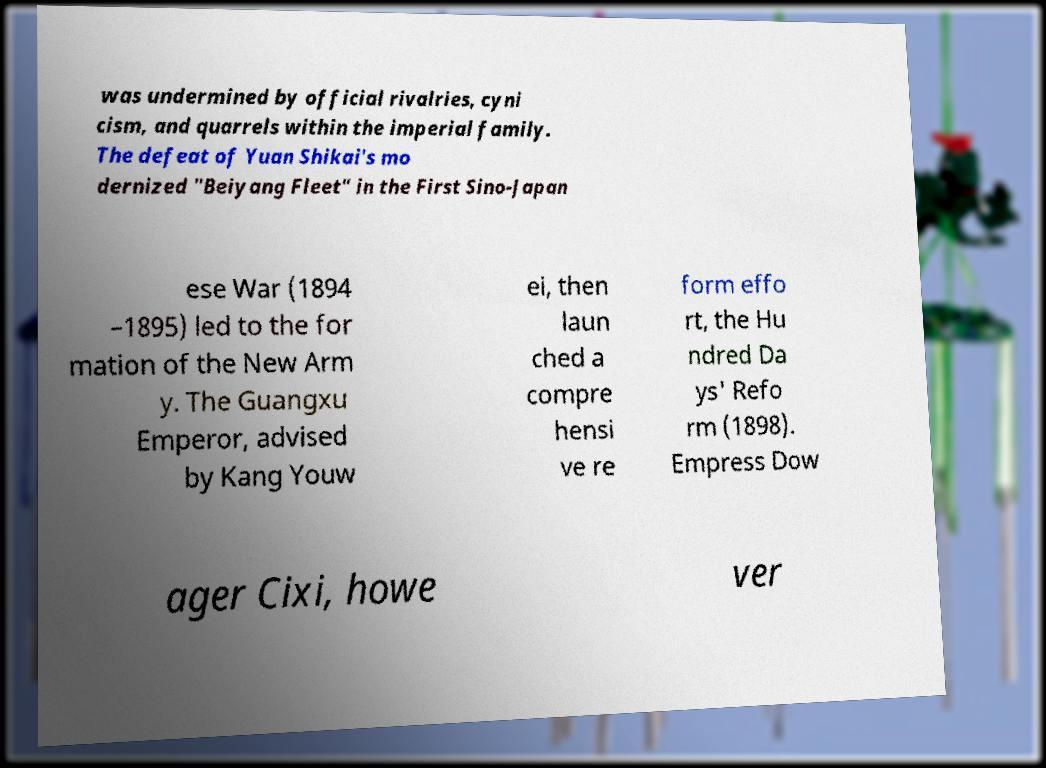Please identify and transcribe the text found in this image. was undermined by official rivalries, cyni cism, and quarrels within the imperial family. The defeat of Yuan Shikai's mo dernized "Beiyang Fleet" in the First Sino-Japan ese War (1894 –1895) led to the for mation of the New Arm y. The Guangxu Emperor, advised by Kang Youw ei, then laun ched a compre hensi ve re form effo rt, the Hu ndred Da ys' Refo rm (1898). Empress Dow ager Cixi, howe ver 